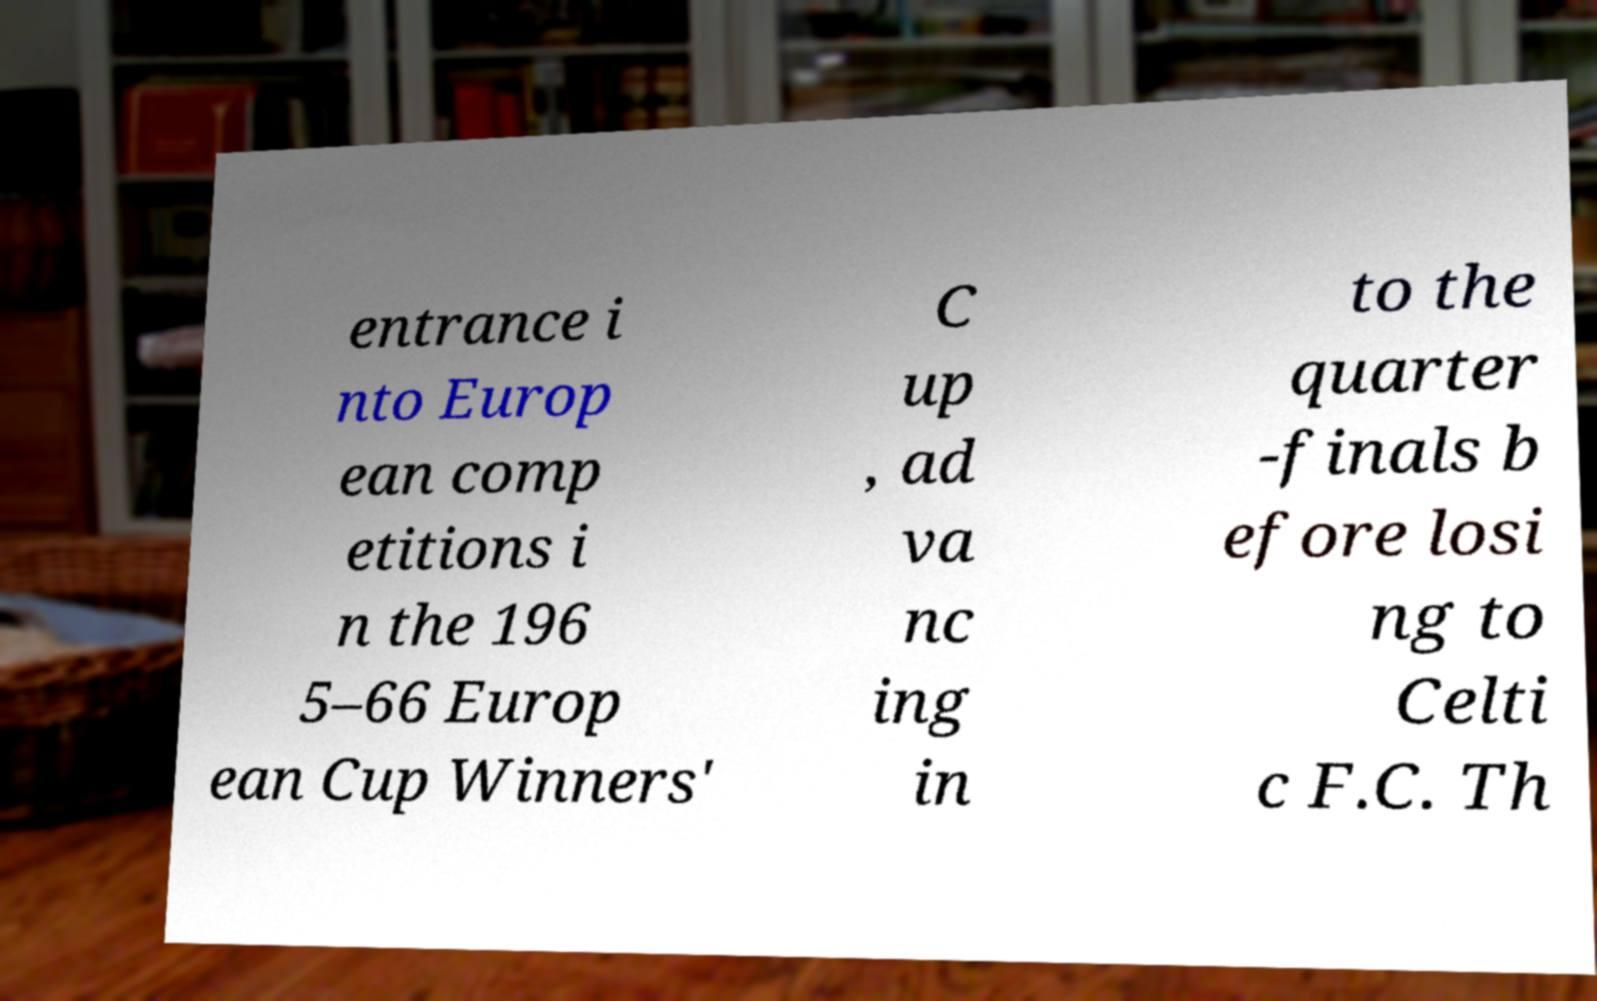There's text embedded in this image that I need extracted. Can you transcribe it verbatim? entrance i nto Europ ean comp etitions i n the 196 5–66 Europ ean Cup Winners' C up , ad va nc ing in to the quarter -finals b efore losi ng to Celti c F.C. Th 